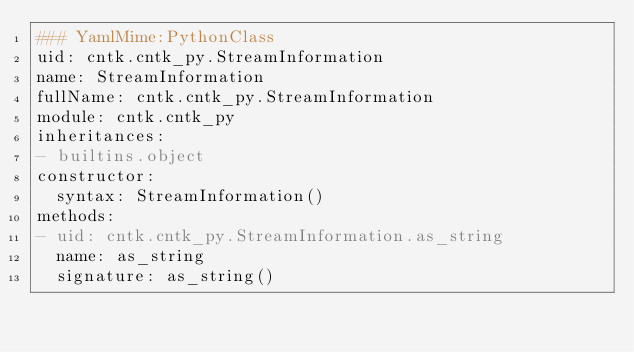<code> <loc_0><loc_0><loc_500><loc_500><_YAML_>### YamlMime:PythonClass
uid: cntk.cntk_py.StreamInformation
name: StreamInformation
fullName: cntk.cntk_py.StreamInformation
module: cntk.cntk_py
inheritances:
- builtins.object
constructor:
  syntax: StreamInformation()
methods:
- uid: cntk.cntk_py.StreamInformation.as_string
  name: as_string
  signature: as_string()
</code> 